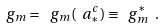<formula> <loc_0><loc_0><loc_500><loc_500>\ g _ { m } = \ g _ { m } ( \ a _ { * } ^ { c } ) \equiv \ g _ { m } ^ { * } \ .</formula> 